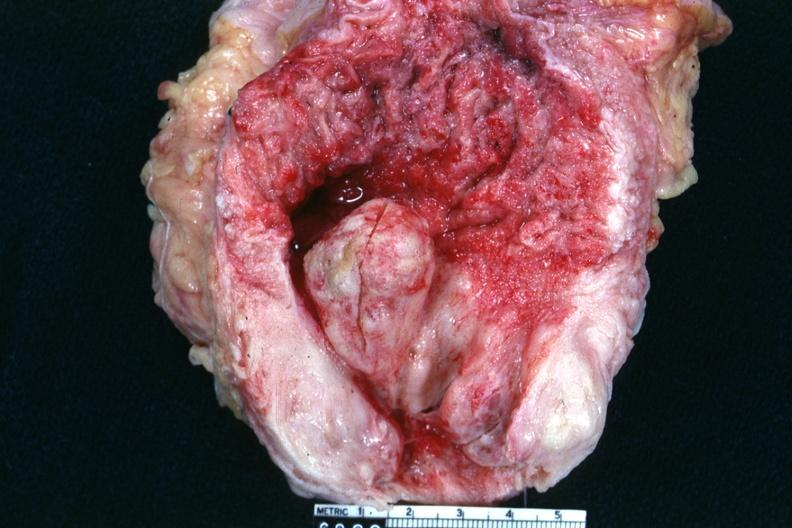what does this image show?
Answer the question using a single word or phrase. Opened bladder with very large prostate gland and high median lobe extending into floor of bladder inflamed bladder mucosa and very hypertrophied bladder 